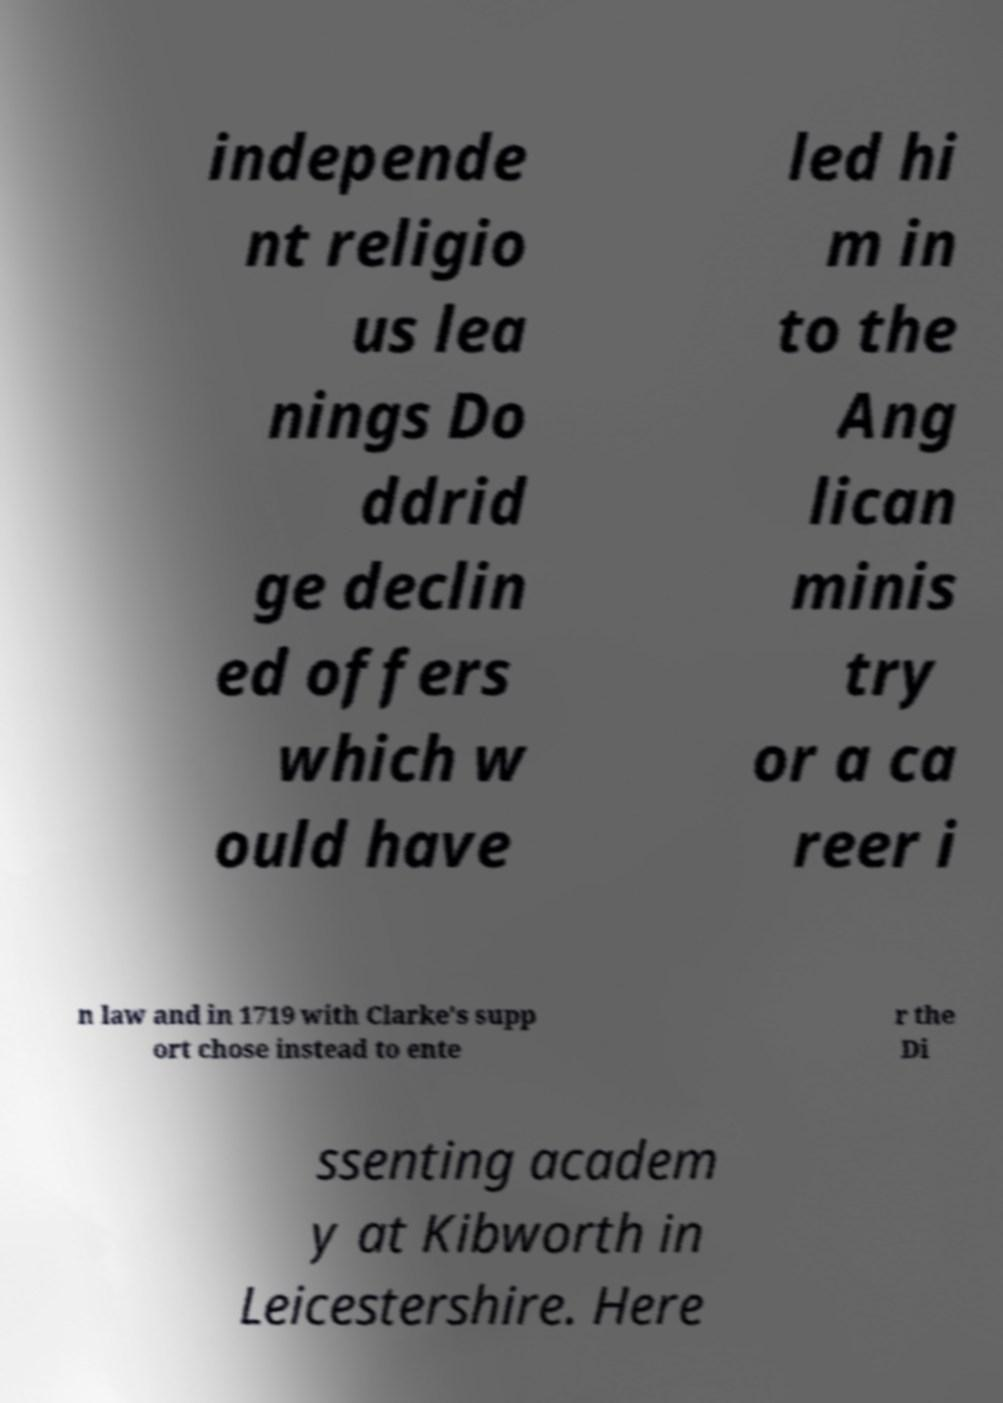Please read and relay the text visible in this image. What does it say? independe nt religio us lea nings Do ddrid ge declin ed offers which w ould have led hi m in to the Ang lican minis try or a ca reer i n law and in 1719 with Clarke's supp ort chose instead to ente r the Di ssenting academ y at Kibworth in Leicestershire. Here 